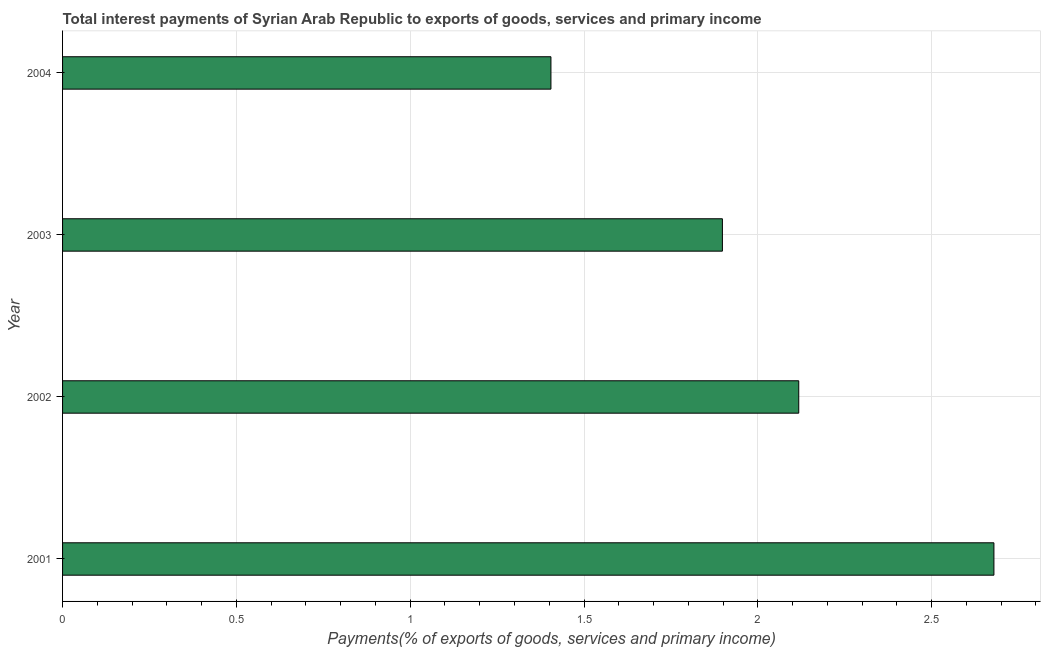What is the title of the graph?
Provide a succinct answer. Total interest payments of Syrian Arab Republic to exports of goods, services and primary income. What is the label or title of the X-axis?
Make the answer very short. Payments(% of exports of goods, services and primary income). What is the label or title of the Y-axis?
Offer a terse response. Year. What is the total interest payments on external debt in 2004?
Offer a very short reply. 1.4. Across all years, what is the maximum total interest payments on external debt?
Your answer should be very brief. 2.68. Across all years, what is the minimum total interest payments on external debt?
Offer a very short reply. 1.4. What is the sum of the total interest payments on external debt?
Offer a terse response. 8.1. What is the difference between the total interest payments on external debt in 2001 and 2002?
Your answer should be very brief. 0.56. What is the average total interest payments on external debt per year?
Make the answer very short. 2.02. What is the median total interest payments on external debt?
Make the answer very short. 2.01. In how many years, is the total interest payments on external debt greater than 1.7 %?
Provide a succinct answer. 3. Do a majority of the years between 2002 and 2004 (inclusive) have total interest payments on external debt greater than 2.7 %?
Make the answer very short. No. What is the ratio of the total interest payments on external debt in 2001 to that in 2002?
Your answer should be compact. 1.26. Is the difference between the total interest payments on external debt in 2002 and 2004 greater than the difference between any two years?
Ensure brevity in your answer.  No. What is the difference between the highest and the second highest total interest payments on external debt?
Offer a very short reply. 0.56. What is the difference between the highest and the lowest total interest payments on external debt?
Your response must be concise. 1.27. How many bars are there?
Offer a very short reply. 4. Are all the bars in the graph horizontal?
Ensure brevity in your answer.  Yes. What is the Payments(% of exports of goods, services and primary income) in 2001?
Your answer should be very brief. 2.68. What is the Payments(% of exports of goods, services and primary income) in 2002?
Ensure brevity in your answer.  2.12. What is the Payments(% of exports of goods, services and primary income) of 2003?
Make the answer very short. 1.9. What is the Payments(% of exports of goods, services and primary income) in 2004?
Ensure brevity in your answer.  1.4. What is the difference between the Payments(% of exports of goods, services and primary income) in 2001 and 2002?
Provide a succinct answer. 0.56. What is the difference between the Payments(% of exports of goods, services and primary income) in 2001 and 2003?
Keep it short and to the point. 0.78. What is the difference between the Payments(% of exports of goods, services and primary income) in 2001 and 2004?
Make the answer very short. 1.27. What is the difference between the Payments(% of exports of goods, services and primary income) in 2002 and 2003?
Your answer should be compact. 0.22. What is the difference between the Payments(% of exports of goods, services and primary income) in 2002 and 2004?
Provide a short and direct response. 0.71. What is the difference between the Payments(% of exports of goods, services and primary income) in 2003 and 2004?
Your response must be concise. 0.49. What is the ratio of the Payments(% of exports of goods, services and primary income) in 2001 to that in 2002?
Keep it short and to the point. 1.26. What is the ratio of the Payments(% of exports of goods, services and primary income) in 2001 to that in 2003?
Offer a terse response. 1.41. What is the ratio of the Payments(% of exports of goods, services and primary income) in 2001 to that in 2004?
Make the answer very short. 1.91. What is the ratio of the Payments(% of exports of goods, services and primary income) in 2002 to that in 2003?
Make the answer very short. 1.12. What is the ratio of the Payments(% of exports of goods, services and primary income) in 2002 to that in 2004?
Your answer should be very brief. 1.51. What is the ratio of the Payments(% of exports of goods, services and primary income) in 2003 to that in 2004?
Give a very brief answer. 1.35. 